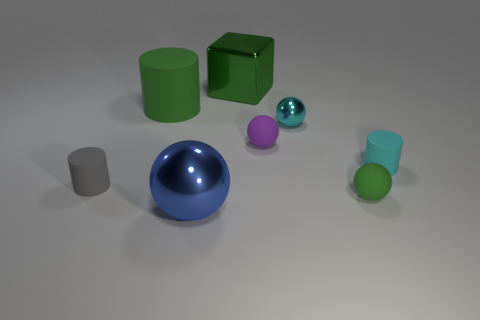Add 2 big things. How many objects exist? 10 Subtract all cylinders. How many objects are left? 5 Subtract 1 cyan cylinders. How many objects are left? 7 Subtract all rubber blocks. Subtract all gray objects. How many objects are left? 7 Add 4 cubes. How many cubes are left? 5 Add 7 large cyan matte spheres. How many large cyan matte spheres exist? 7 